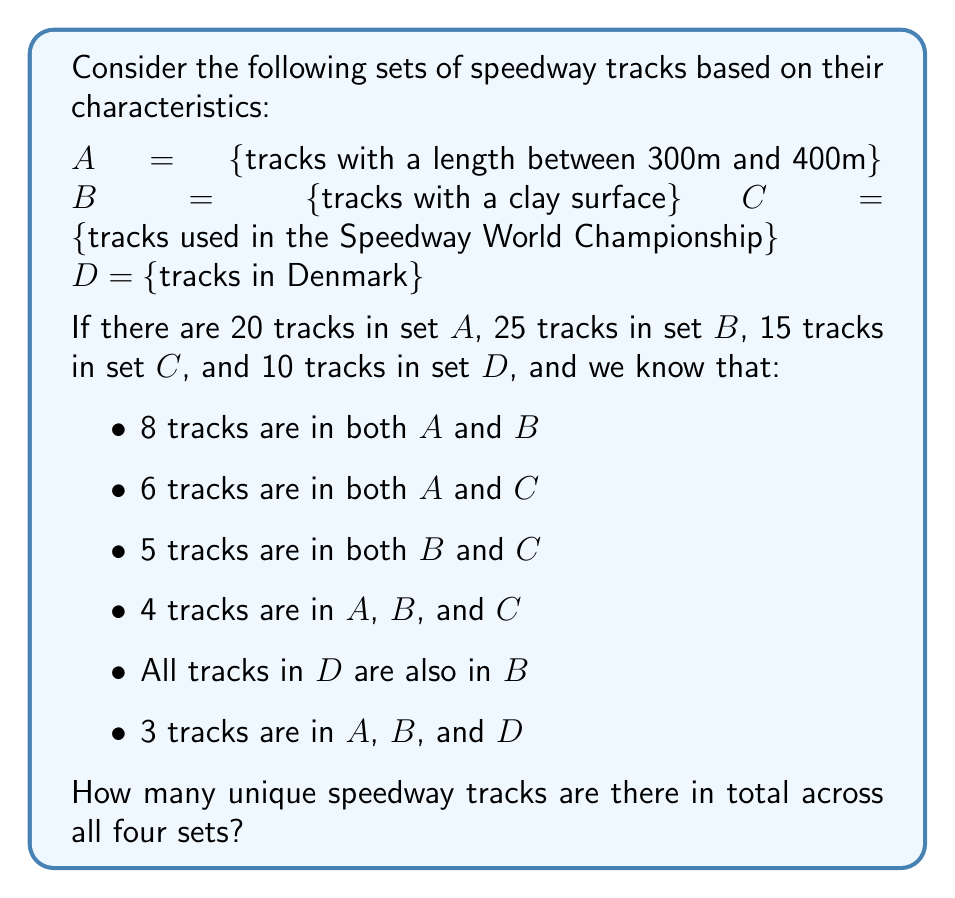Can you solve this math problem? To solve this problem, we'll use the Inclusion-Exclusion Principle from set theory. Let's break it down step by step:

1) First, let's find $|A \cup B \cup C|$ (the number of tracks in $A$ or $B$ or $C$):

   $|A \cup B \cup C| = |A| + |B| + |C| - |A \cap B| - |A \cap C| - |B \cap C| + |A \cap B \cap C|$

   $= 20 + 25 + 15 - 8 - 6 - 5 + 4 = 45$

2) Now, we need to consider set $D$. We know that $D \subseteq B$ (all tracks in $D$ are also in $B$), so we don't need to add $|D|$ separately.

3) However, we need to subtract the tracks in $D$ that we've counted twice. These are the tracks in $D$ that are also in $A$ or $C$.

4) We know that $|A \cap B \cap D| = 3$. This means there are 3 tracks in $D$ that are also in $A$.

5) For $D \cap C$, we don't have direct information. But since $D \subseteq B$, any track in $D \cap C$ must also be in $B \cap C$. We know $|B \cap C| = 5$, so $|D \cap C|$ can be at most 5.

6) To minimize our total count (giving us the minimum number of unique tracks), let's assume $|D \cap C| = 5$.

7) Now we can calculate the total number of unique tracks:

   $|A \cup B \cup C \cup D| = |A \cup B \cup C| - |A \cap D| - |C \cap D| + |A \cap C \cap D|$

   $= 45 - 3 - 5 + |A \cap C \cap D|$

8) We don't know $|A \cap C \cap D|$ exactly, but we know it's at least 0 and at most 3 (since $|A \cap B \cap D| = 3$ and $D \subseteq B$).

9) To minimize our count, let's assume $|A \cap C \cap D| = 0$.

Therefore, the minimum number of unique tracks is:

$45 - 3 - 5 + 0 = 37$
Answer: There are at least 37 unique speedway tracks across all four sets. 